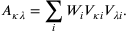Convert formula to latex. <formula><loc_0><loc_0><loc_500><loc_500>A _ { \kappa \lambda } = \sum _ { i } W _ { i } V _ { \kappa i } V _ { \lambda i } .</formula> 